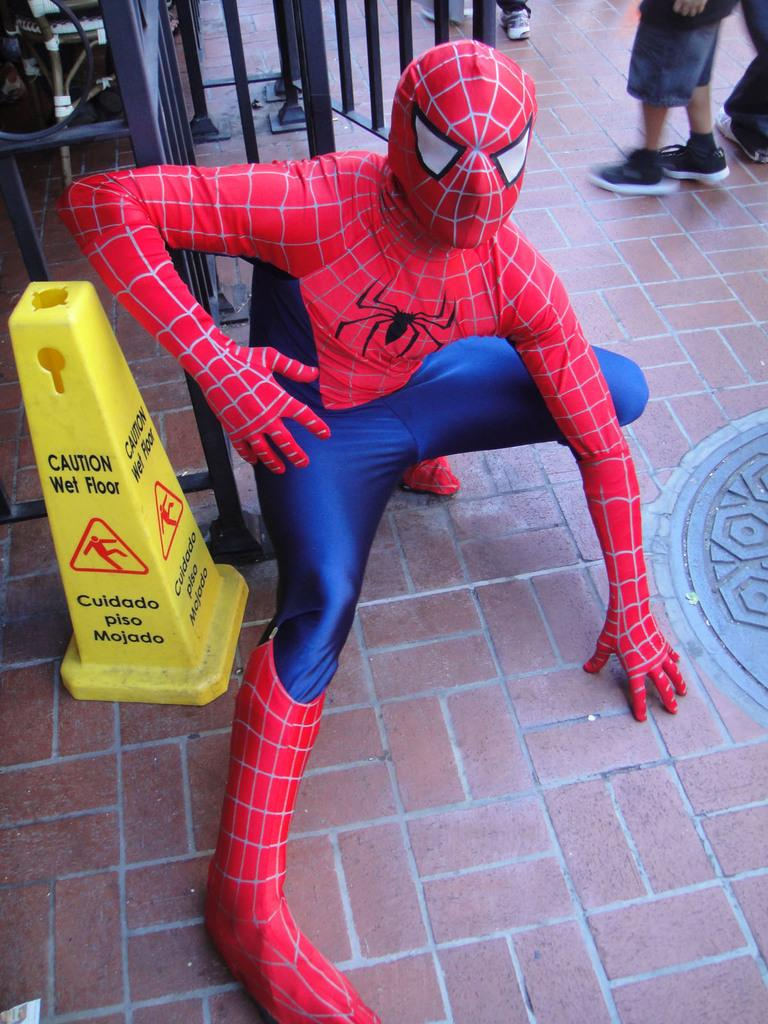What is the main subject of the image? The main subject of the image is a man. What is the man wearing in the image? The man is wearing a Spider-Man dress in the image. What is the man's opinion on the creature in the soup in the image? There is no creature or soup present in the image, so it is not possible to determine the man's opinion on such a scenario. 